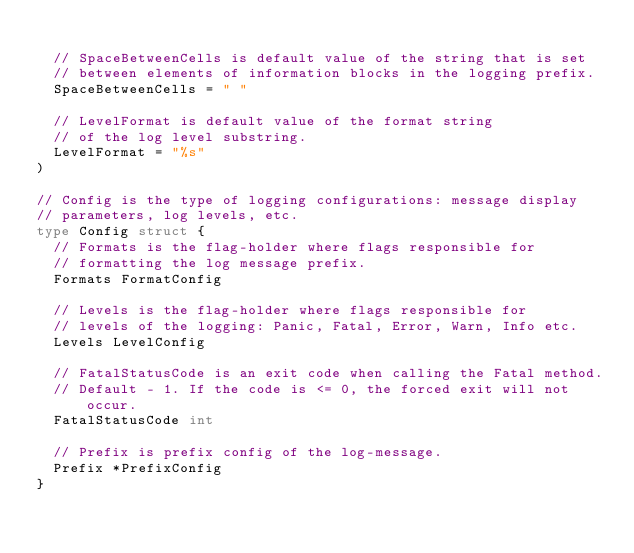<code> <loc_0><loc_0><loc_500><loc_500><_Go_>
	// SpaceBetweenCells is default value of the string that is set
	// between elements of information blocks in the logging prefix.
	SpaceBetweenCells = " "

	// LevelFormat is default value of the format string
	// of the log level substring.
	LevelFormat = "%s"
)

// Config is the type of logging configurations: message display
// parameters, log levels, etc.
type Config struct {
	// Formats is the flag-holder where flags responsible for
	// formatting the log message prefix.
	Formats FormatConfig

	// Levels is the flag-holder where flags responsible for
	// levels of the logging: Panic, Fatal, Error, Warn, Info etc.
	Levels LevelConfig

	// FatalStatusCode is an exit code when calling the Fatal method.
	// Default - 1. If the code is <= 0, the forced exit will not occur.
	FatalStatusCode int

	// Prefix is prefix config of the log-message.
	Prefix *PrefixConfig
}
</code> 